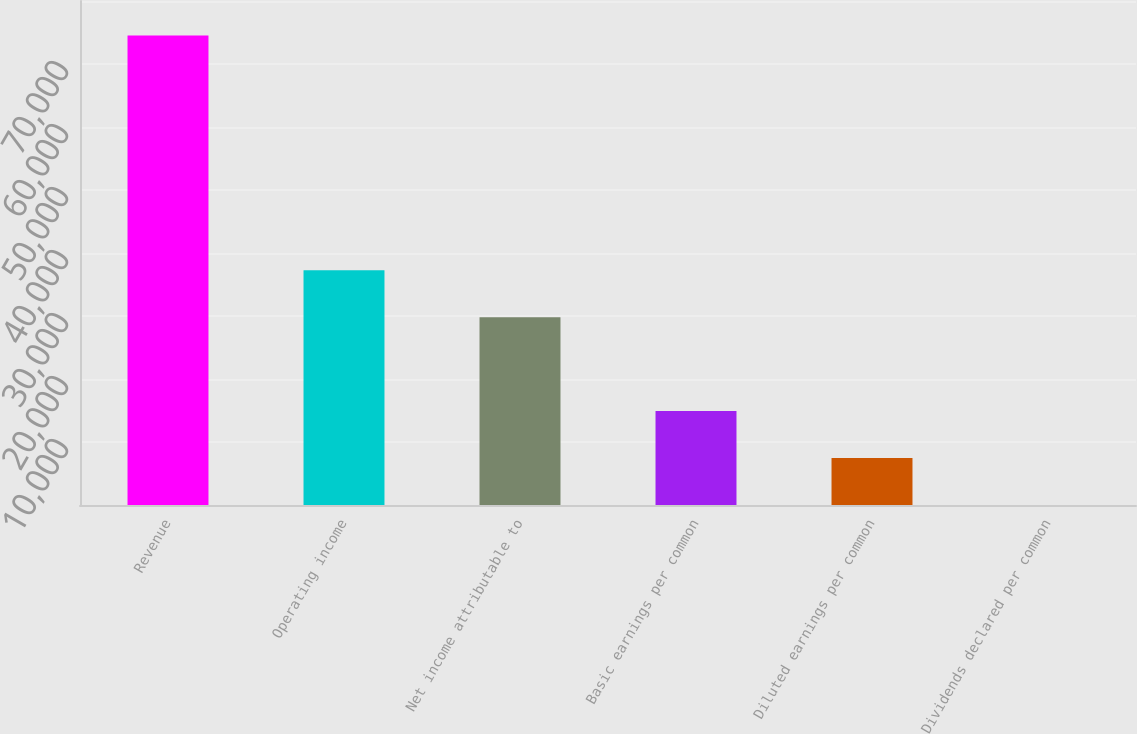<chart> <loc_0><loc_0><loc_500><loc_500><bar_chart><fcel>Revenue<fcel>Operating income<fcel>Net income attributable to<fcel>Basic earnings per common<fcel>Diluted earnings per common<fcel>Dividends declared per common<nl><fcel>74510<fcel>37255.5<fcel>29804.6<fcel>14902.8<fcel>7451.9<fcel>1<nl></chart> 